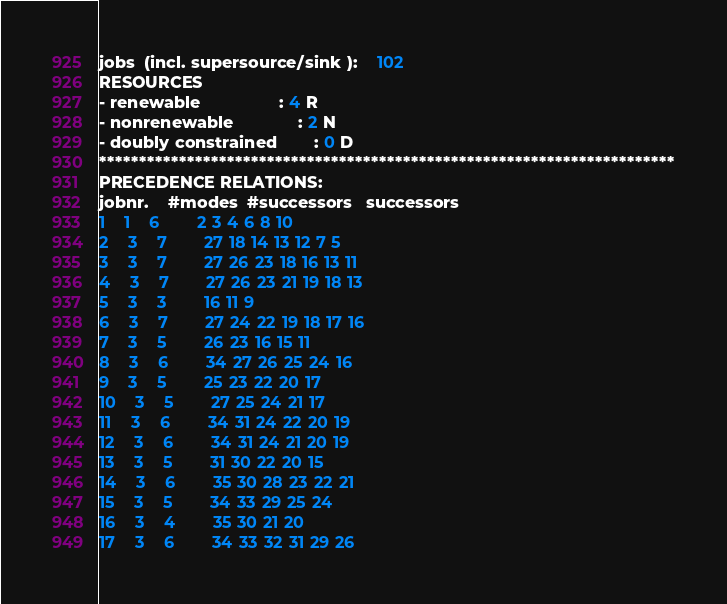<code> <loc_0><loc_0><loc_500><loc_500><_ObjectiveC_>jobs  (incl. supersource/sink ):	102
RESOURCES
- renewable                 : 4 R
- nonrenewable              : 2 N
- doubly constrained        : 0 D
************************************************************************
PRECEDENCE RELATIONS:
jobnr.    #modes  #successors   successors
1	1	6		2 3 4 6 8 10 
2	3	7		27 18 14 13 12 7 5 
3	3	7		27 26 23 18 16 13 11 
4	3	7		27 26 23 21 19 18 13 
5	3	3		16 11 9 
6	3	7		27 24 22 19 18 17 16 
7	3	5		26 23 16 15 11 
8	3	6		34 27 26 25 24 16 
9	3	5		25 23 22 20 17 
10	3	5		27 25 24 21 17 
11	3	6		34 31 24 22 20 19 
12	3	6		34 31 24 21 20 19 
13	3	5		31 30 22 20 15 
14	3	6		35 30 28 23 22 21 
15	3	5		34 33 29 25 24 
16	3	4		35 30 21 20 
17	3	6		34 33 32 31 29 26 </code> 